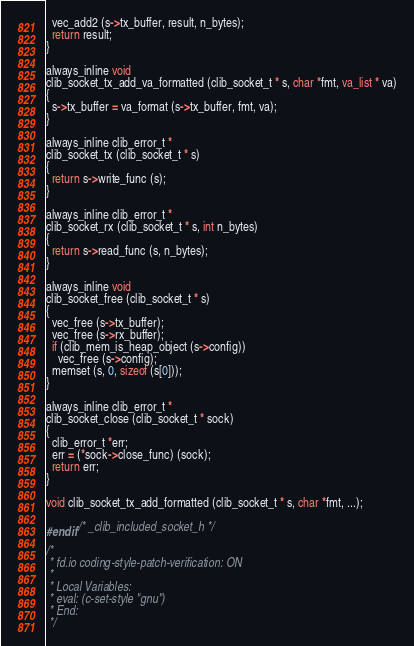Convert code to text. <code><loc_0><loc_0><loc_500><loc_500><_C_>  vec_add2 (s->tx_buffer, result, n_bytes);
  return result;
}

always_inline void
clib_socket_tx_add_va_formatted (clib_socket_t * s, char *fmt, va_list * va)
{
  s->tx_buffer = va_format (s->tx_buffer, fmt, va);
}

always_inline clib_error_t *
clib_socket_tx (clib_socket_t * s)
{
  return s->write_func (s);
}

always_inline clib_error_t *
clib_socket_rx (clib_socket_t * s, int n_bytes)
{
  return s->read_func (s, n_bytes);
}

always_inline void
clib_socket_free (clib_socket_t * s)
{
  vec_free (s->tx_buffer);
  vec_free (s->rx_buffer);
  if (clib_mem_is_heap_object (s->config))
    vec_free (s->config);
  memset (s, 0, sizeof (s[0]));
}

always_inline clib_error_t *
clib_socket_close (clib_socket_t * sock)
{
  clib_error_t *err;
  err = (*sock->close_func) (sock);
  return err;
}

void clib_socket_tx_add_formatted (clib_socket_t * s, char *fmt, ...);

#endif /* _clib_included_socket_h */

/*
 * fd.io coding-style-patch-verification: ON
 *
 * Local Variables:
 * eval: (c-set-style "gnu")
 * End:
 */
</code> 